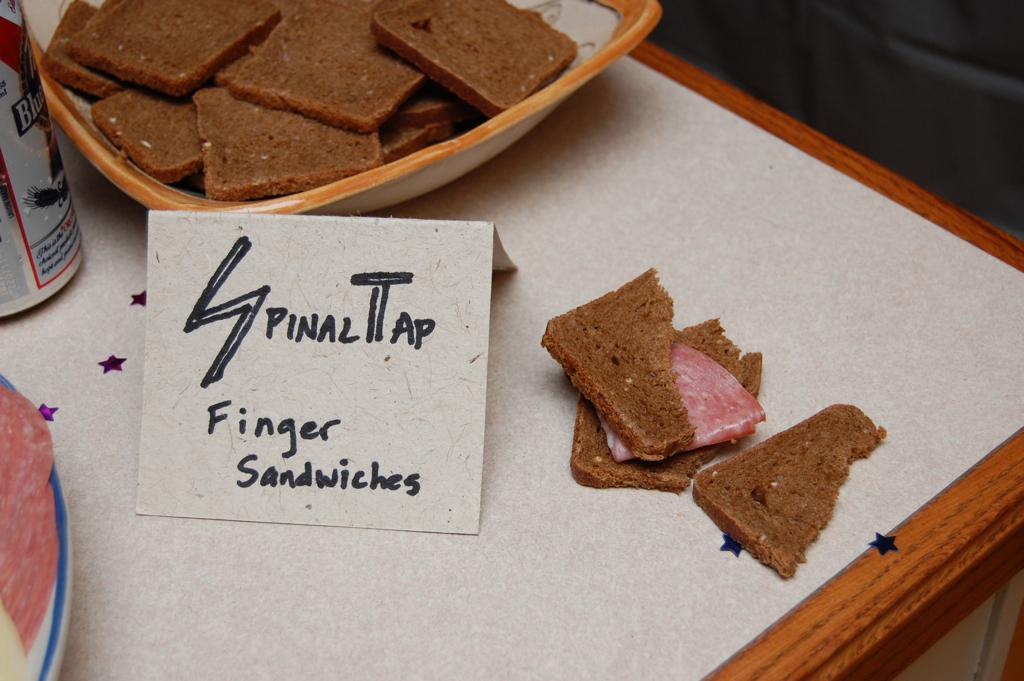What is in the bowl that is visible in the image? There are food items in a bowl in the image. Where is the bowl of food items located? The bowl of food items is on a table. What other objects can be seen on the table in the image? There are no other objects mentioned on the table, but there are other objects on a white color surface on the left side of the image. What type of match can be seen between the boys in the image? There are no boys present in the image, and therefore no match can be observed between them. 